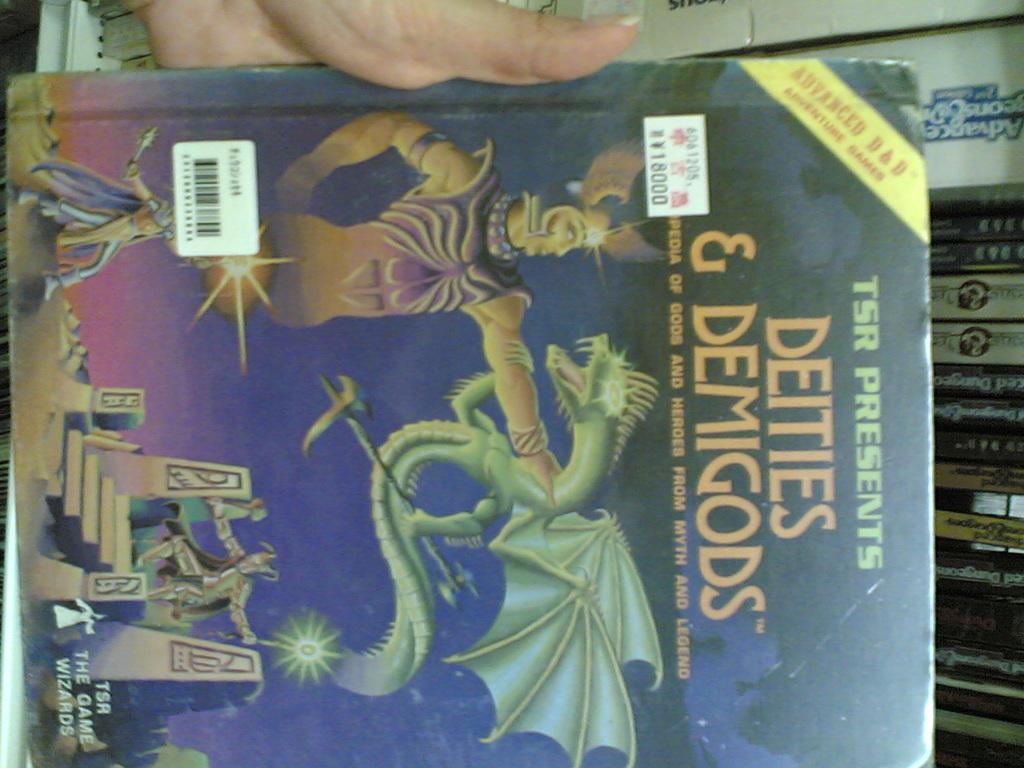What are the deities accompanied by based on the title of this book?
Your answer should be compact. Demigods. What company presents this book?
Make the answer very short. Tsr. 